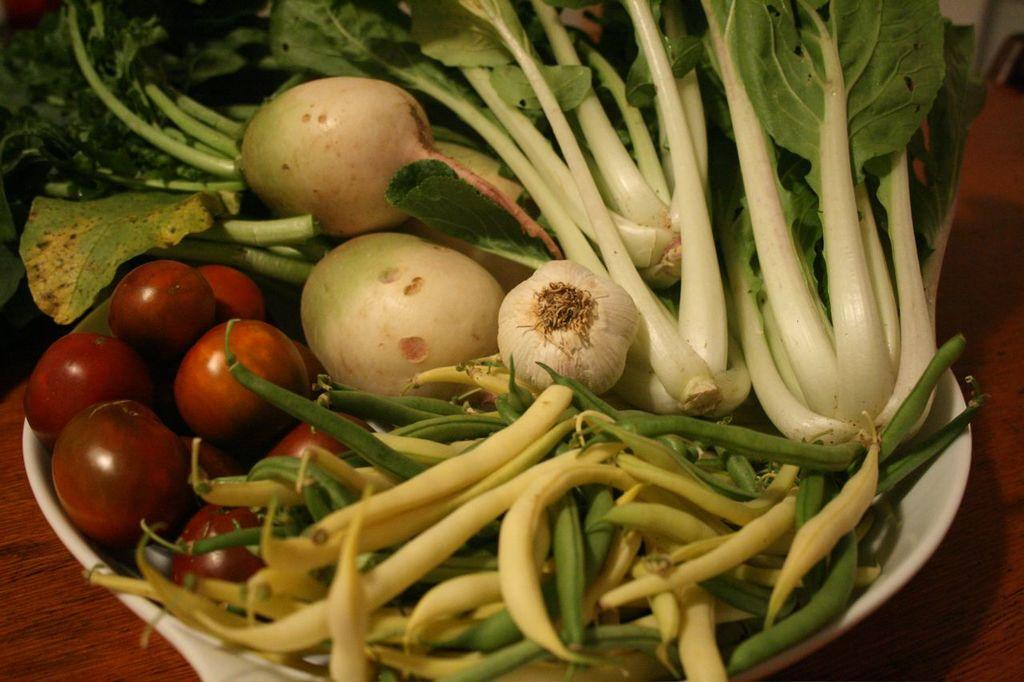What type of food is visible in the image? There are vegetables in the image. What colors can be seen in the vegetables? The vegetables are in red, green, and white colors. Where are the vegetables located in the image? The vegetables are in a bowl. What color is the bowl? The bowl is white in color. On what surface is the bowl placed? The bowl is on a table. What type of wrench is being used to cut the vegetables in the image? There is no wrench present in the image, and the vegetables are not being cut. The vegetables are simply in a bowl on a table. 